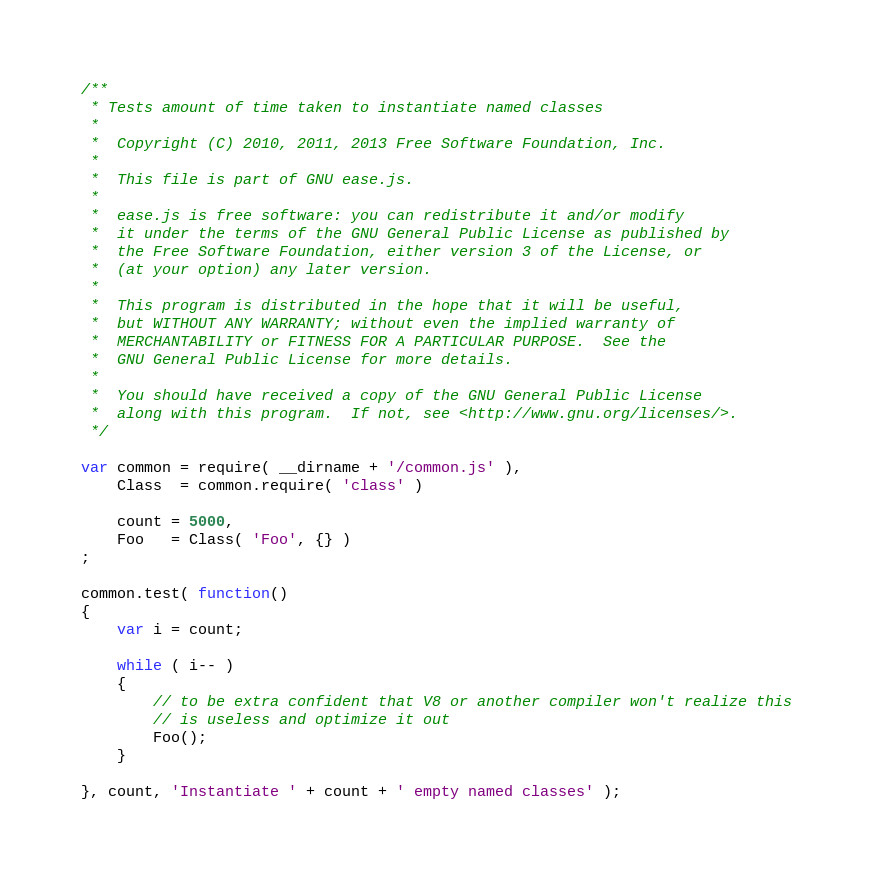Convert code to text. <code><loc_0><loc_0><loc_500><loc_500><_JavaScript_>/**
 * Tests amount of time taken to instantiate named classes
 *
 *  Copyright (C) 2010, 2011, 2013 Free Software Foundation, Inc.
 *
 *  This file is part of GNU ease.js.
 *
 *  ease.js is free software: you can redistribute it and/or modify
 *  it under the terms of the GNU General Public License as published by
 *  the Free Software Foundation, either version 3 of the License, or
 *  (at your option) any later version.
 *
 *  This program is distributed in the hope that it will be useful,
 *  but WITHOUT ANY WARRANTY; without even the implied warranty of
 *  MERCHANTABILITY or FITNESS FOR A PARTICULAR PURPOSE.  See the
 *  GNU General Public License for more details.
 *
 *  You should have received a copy of the GNU General Public License
 *  along with this program.  If not, see <http://www.gnu.org/licenses/>.
 */

var common = require( __dirname + '/common.js' ),
    Class  = common.require( 'class' )

    count = 5000,
    Foo   = Class( 'Foo', {} )
;

common.test( function()
{
    var i = count;

    while ( i-- )
    {
        // to be extra confident that V8 or another compiler won't realize this
        // is useless and optimize it out
        Foo();
    }

}, count, 'Instantiate ' + count + ' empty named classes' );
</code> 